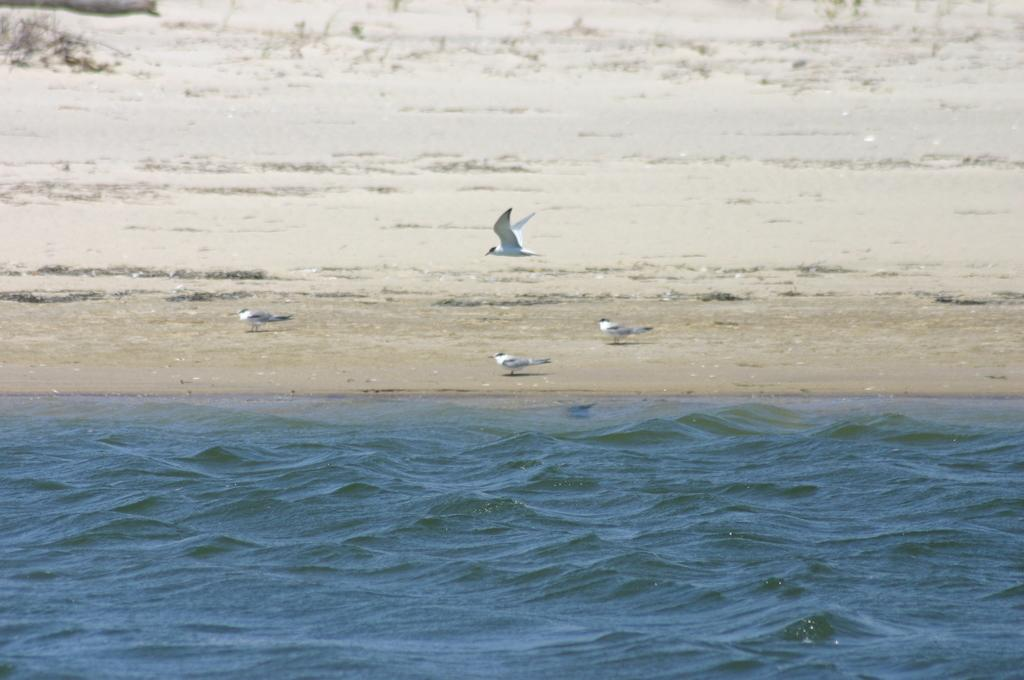What animals can be seen in the image? There are birds standing on the sand and a bird flying in the air in the image. What type of terrain is visible in the image? The birds are standing on sand in the image. What else can be seen in the image besides the birds? There is water visible in the image. What type of loaf is being baked in the image? There is no loaf present in the image; it features birds on sand and water. What type of structure can be seen in the background of the image? There is no structure visible in the image; it only shows birds, sand, and water. 